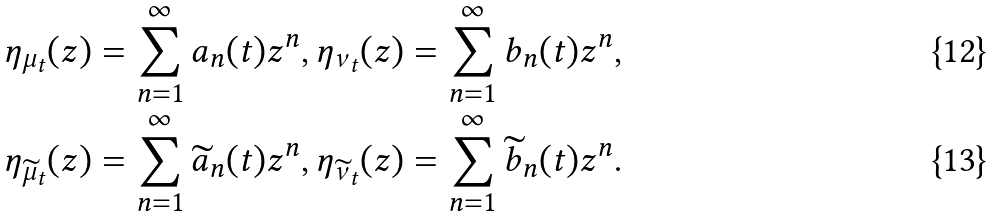Convert formula to latex. <formula><loc_0><loc_0><loc_500><loc_500>& \eta _ { \mu _ { t } } ( z ) = \sum _ { n = 1 } ^ { \infty } a _ { n } ( t ) z ^ { n } , \eta _ { \nu _ { t } } ( z ) = \sum _ { n = 1 } ^ { \infty } b _ { n } ( t ) z ^ { n } , \\ & \eta _ { \widetilde { \mu } _ { t } } ( z ) = \sum _ { n = 1 } ^ { \infty } \widetilde { a } _ { n } ( t ) z ^ { n } , \eta _ { \widetilde { \nu } _ { t } } ( z ) = \sum _ { n = 1 } ^ { \infty } \widetilde { b } _ { n } ( t ) z ^ { n } .</formula> 